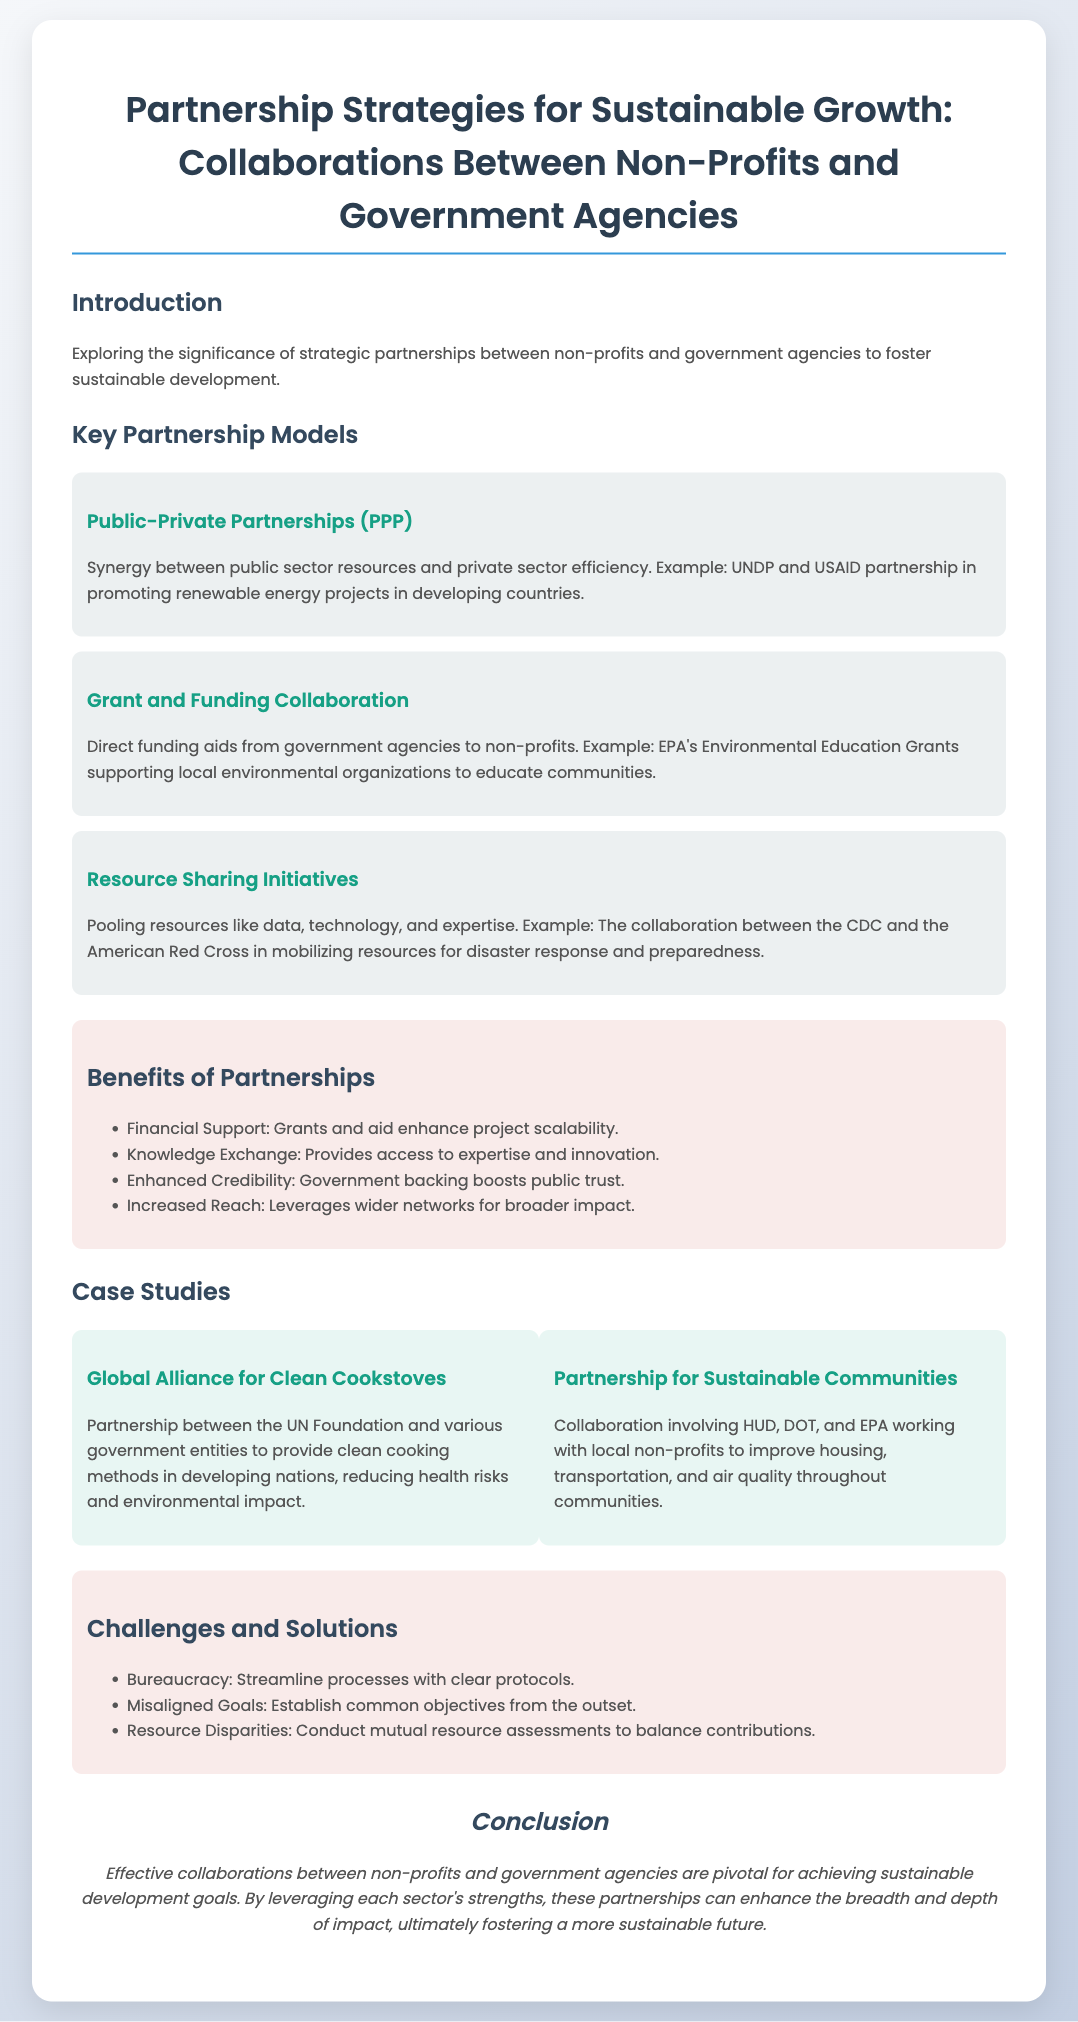What is the title of the presentation? The title is prominently displayed at the top of the document and is "Partnership Strategies for Sustainable Growth: Collaborations Between Non-Profits and Government Agencies."
Answer: Partnership Strategies for Sustainable Growth: Collaborations Between Non-Profits and Government Agencies What is one example of a Public-Private Partnership? The document contains an example of a partnership between UNDP and USAID in promoting renewable energy projects in developing countries.
Answer: UNDP and USAID What is one benefit of partnerships mentioned in the document? The document lists several benefits, one of which is "Financial Support: Grants and aid enhance project scalability."
Answer: Financial Support How many case studies are presented in the document? There are two specific case studies highlighted in the case studies section.
Answer: 2 What challenge is associated with misaligned goals? The document notes that misaligned goals can be addressed by "Establish[ing] common objectives from the outset."
Answer: Establish common objectives What government agency is involved in the Partnership for Sustainable Communities? The document mentions several agencies, including HUD, DOT, and EPA as part of this collaboration.
Answer: HUD, DOT, EPA What solution is suggested for the challenge of bureaucracy? A solution provided in the document is to "Streamline processes with clear protocols."
Answer: Streamline processes What is the conclusion of the presentation? The conclusion emphasizes that "Effective collaborations between non-profits and government agencies are pivotal for achieving sustainable development goals."
Answer: Effective collaborations are pivotal for achieving sustainable development goals 